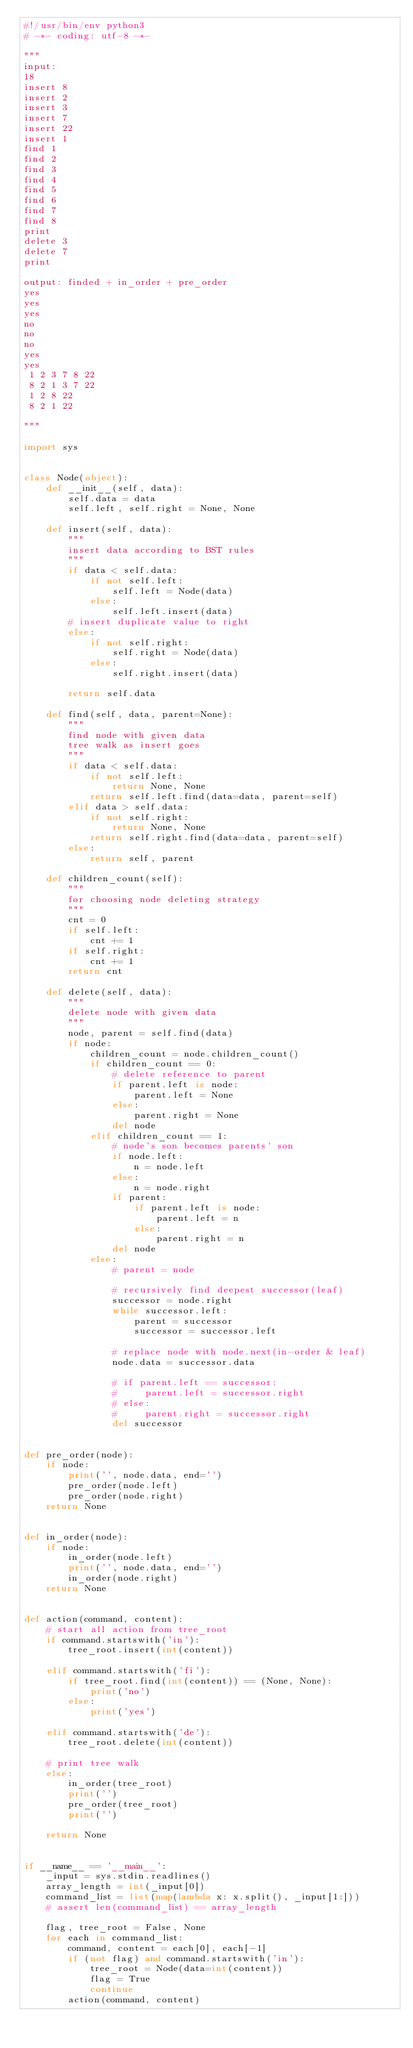Convert code to text. <code><loc_0><loc_0><loc_500><loc_500><_Python_>#!/usr/bin/env python3
# -*- coding: utf-8 -*-

"""
input:
18
insert 8
insert 2
insert 3
insert 7
insert 22
insert 1
find 1
find 2
find 3
find 4
find 5
find 6
find 7
find 8
print
delete 3
delete 7
print

output: finded + in_order + pre_order
yes
yes
yes
no
no
no
yes
yes
 1 2 3 7 8 22
 8 2 1 3 7 22
 1 2 8 22
 8 2 1 22

"""

import sys


class Node(object):
    def __init__(self, data):
        self.data = data
        self.left, self.right = None, None

    def insert(self, data):
        """
        insert data according to BST rules
        """
        if data < self.data:
            if not self.left:
                self.left = Node(data)
            else:
                self.left.insert(data)
        # insert duplicate value to right
        else:
            if not self.right:
                self.right = Node(data)
            else:
                self.right.insert(data)

        return self.data

    def find(self, data, parent=None):
        """
        find node with given data
        tree walk as insert goes
        """
        if data < self.data:
            if not self.left:
                return None, None
            return self.left.find(data=data, parent=self)
        elif data > self.data:
            if not self.right:
                return None, None
            return self.right.find(data=data, parent=self)
        else:
            return self, parent

    def children_count(self):
        """
        for choosing node deleting strategy
        """
        cnt = 0
        if self.left:
            cnt += 1
        if self.right:
            cnt += 1
        return cnt

    def delete(self, data):
        """
        delete node with given data
        """
        node, parent = self.find(data)
        if node:
            children_count = node.children_count()
            if children_count == 0:
                # delete reference to parent
                if parent.left is node:
                    parent.left = None
                else:
                    parent.right = None
                del node
            elif children_count == 1:
                # node's son becomes parents' son
                if node.left:
                    n = node.left
                else:
                    n = node.right
                if parent:
                    if parent.left is node:
                        parent.left = n
                    else:
                        parent.right = n
                del node
            else:
                # parent = node

                # recursively find deepest successor(leaf)
                successor = node.right
                while successor.left:
                    parent = successor
                    successor = successor.left

                # replace node with node.next(in-order & leaf)
                node.data = successor.data

                # if parent.left == successor:
                #     parent.left = successor.right
                # else:
                #     parent.right = successor.right
                del successor


def pre_order(node):
    if node:
        print('', node.data, end='')
        pre_order(node.left)
        pre_order(node.right)
    return None


def in_order(node):
    if node:
        in_order(node.left)
        print('', node.data, end='')
        in_order(node.right)
    return None


def action(command, content):
    # start all action from tree_root
    if command.startswith('in'):
        tree_root.insert(int(content))

    elif command.startswith('fi'):
        if tree_root.find(int(content)) == (None, None):
            print('no')
        else:
            print('yes')

    elif command.startswith('de'):
        tree_root.delete(int(content))

    # print tree walk
    else:
        in_order(tree_root)
        print('')
        pre_order(tree_root)
        print('')

    return None


if __name__ == '__main__':
    _input = sys.stdin.readlines()
    array_length = int(_input[0])
    command_list = list(map(lambda x: x.split(), _input[1:]))
    # assert len(command_list) == array_length

    flag, tree_root = False, None
    for each in command_list:
        command, content = each[0], each[-1]
        if (not flag) and command.startswith('in'):
            tree_root = Node(data=int(content))
            flag = True
            continue
        action(command, content)</code> 